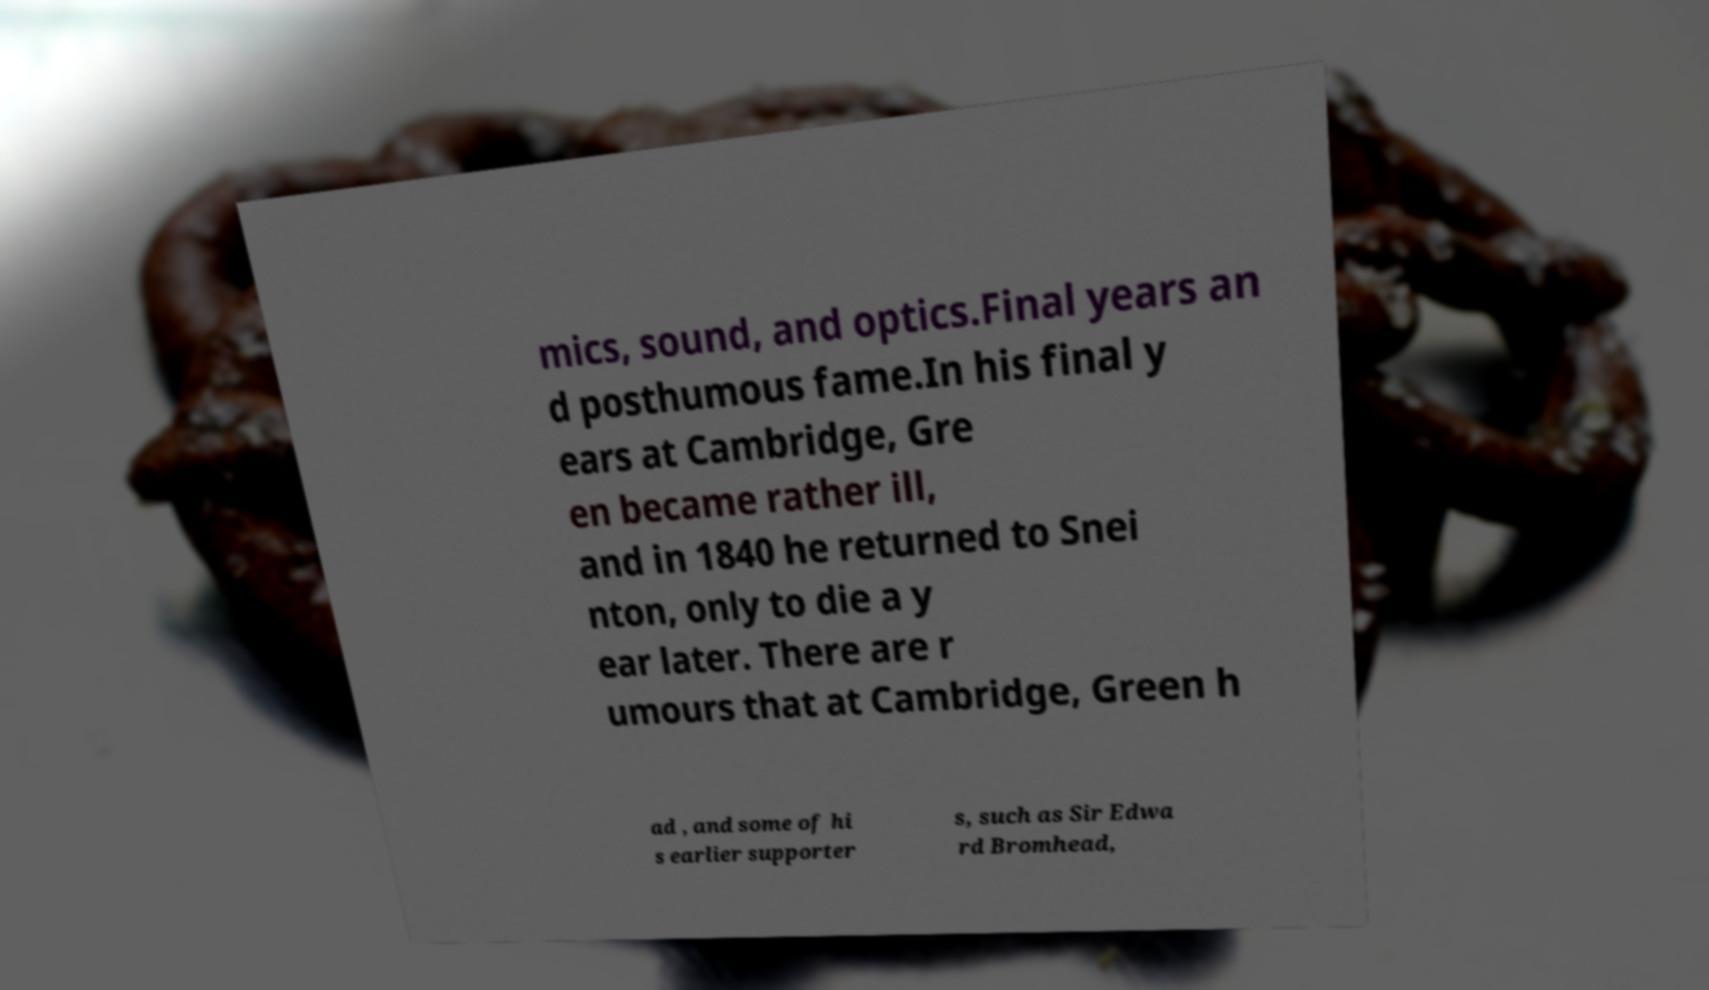Could you assist in decoding the text presented in this image and type it out clearly? mics, sound, and optics.Final years an d posthumous fame.In his final y ears at Cambridge, Gre en became rather ill, and in 1840 he returned to Snei nton, only to die a y ear later. There are r umours that at Cambridge, Green h ad , and some of hi s earlier supporter s, such as Sir Edwa rd Bromhead, 